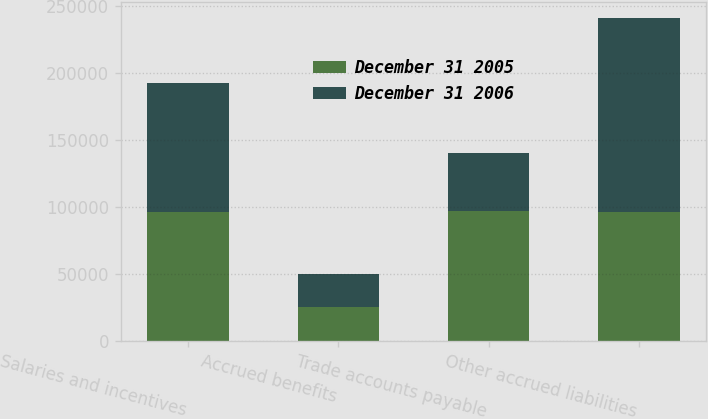Convert chart to OTSL. <chart><loc_0><loc_0><loc_500><loc_500><stacked_bar_chart><ecel><fcel>Salaries and incentives<fcel>Accrued benefits<fcel>Trade accounts payable<fcel>Other accrued liabilities<nl><fcel>December 31 2005<fcel>95681<fcel>25264<fcel>96554<fcel>95681<nl><fcel>December 31 2006<fcel>96492<fcel>24346<fcel>43648<fcel>145105<nl></chart> 